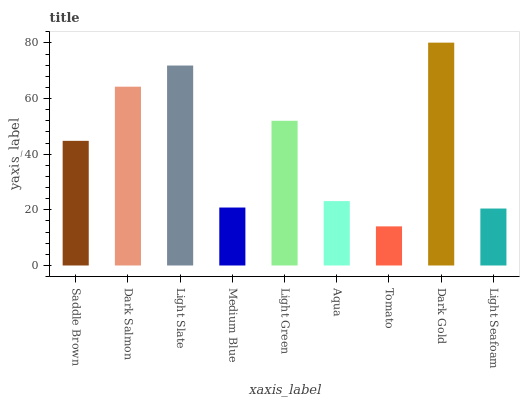Is Tomato the minimum?
Answer yes or no. Yes. Is Dark Gold the maximum?
Answer yes or no. Yes. Is Dark Salmon the minimum?
Answer yes or no. No. Is Dark Salmon the maximum?
Answer yes or no. No. Is Dark Salmon greater than Saddle Brown?
Answer yes or no. Yes. Is Saddle Brown less than Dark Salmon?
Answer yes or no. Yes. Is Saddle Brown greater than Dark Salmon?
Answer yes or no. No. Is Dark Salmon less than Saddle Brown?
Answer yes or no. No. Is Saddle Brown the high median?
Answer yes or no. Yes. Is Saddle Brown the low median?
Answer yes or no. Yes. Is Light Slate the high median?
Answer yes or no. No. Is Dark Salmon the low median?
Answer yes or no. No. 